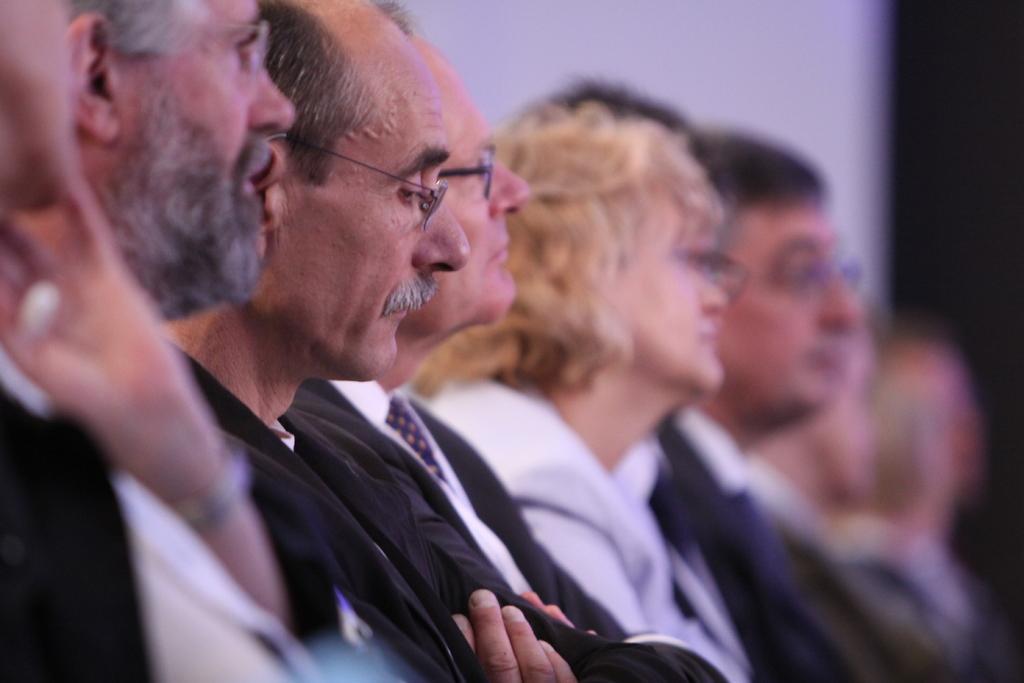In one or two sentences, can you explain what this image depicts? In this image we can see a group of persons. The background of the image is blurred. 